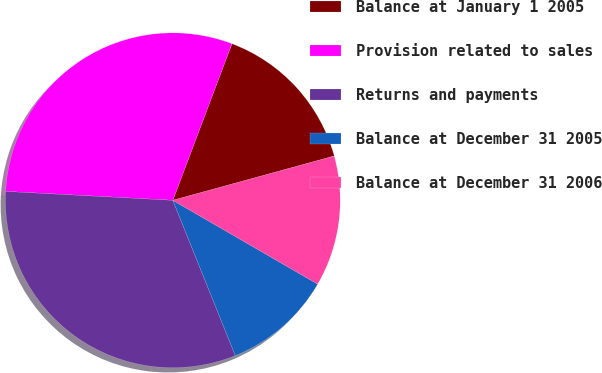<chart> <loc_0><loc_0><loc_500><loc_500><pie_chart><fcel>Balance at January 1 2005<fcel>Provision related to sales<fcel>Returns and payments<fcel>Balance at December 31 2005<fcel>Balance at December 31 2006<nl><fcel>14.99%<fcel>29.9%<fcel>31.94%<fcel>10.56%<fcel>12.61%<nl></chart> 